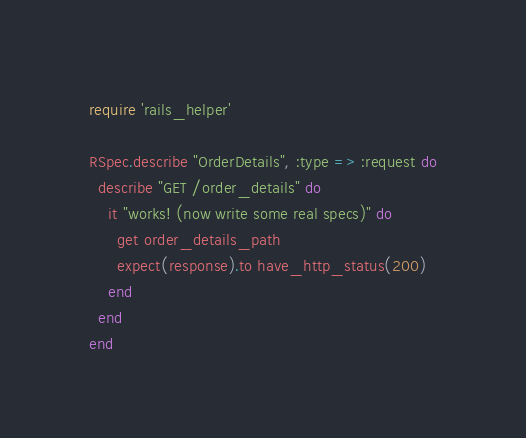Convert code to text. <code><loc_0><loc_0><loc_500><loc_500><_Ruby_>require 'rails_helper'

RSpec.describe "OrderDetails", :type => :request do
  describe "GET /order_details" do
    it "works! (now write some real specs)" do
      get order_details_path
      expect(response).to have_http_status(200)
    end
  end
end
</code> 